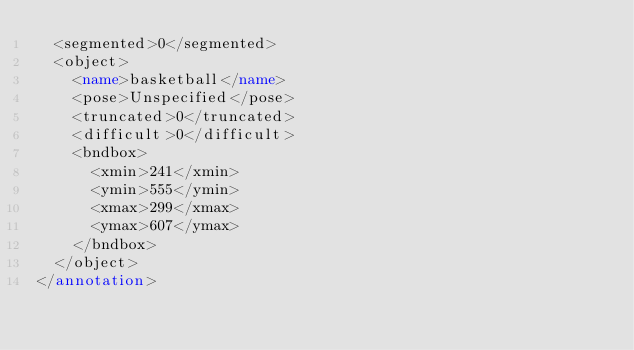<code> <loc_0><loc_0><loc_500><loc_500><_XML_>	<segmented>0</segmented>
	<object>
		<name>basketball</name>
		<pose>Unspecified</pose>
		<truncated>0</truncated>
		<difficult>0</difficult>
		<bndbox>
			<xmin>241</xmin>
			<ymin>555</ymin>
			<xmax>299</xmax>
			<ymax>607</ymax>
		</bndbox>
	</object>
</annotation>
</code> 